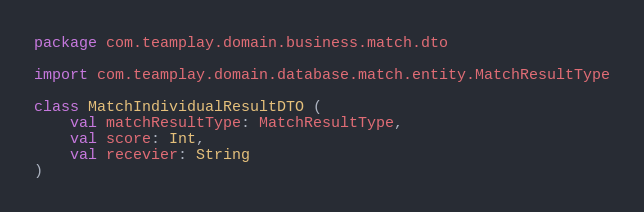Convert code to text. <code><loc_0><loc_0><loc_500><loc_500><_Kotlin_>package com.teamplay.domain.business.match.dto

import com.teamplay.domain.database.match.entity.MatchResultType

class MatchIndividualResultDTO (
    val matchResultType: MatchResultType,
    val score: Int,
    val recevier: String
)
</code> 